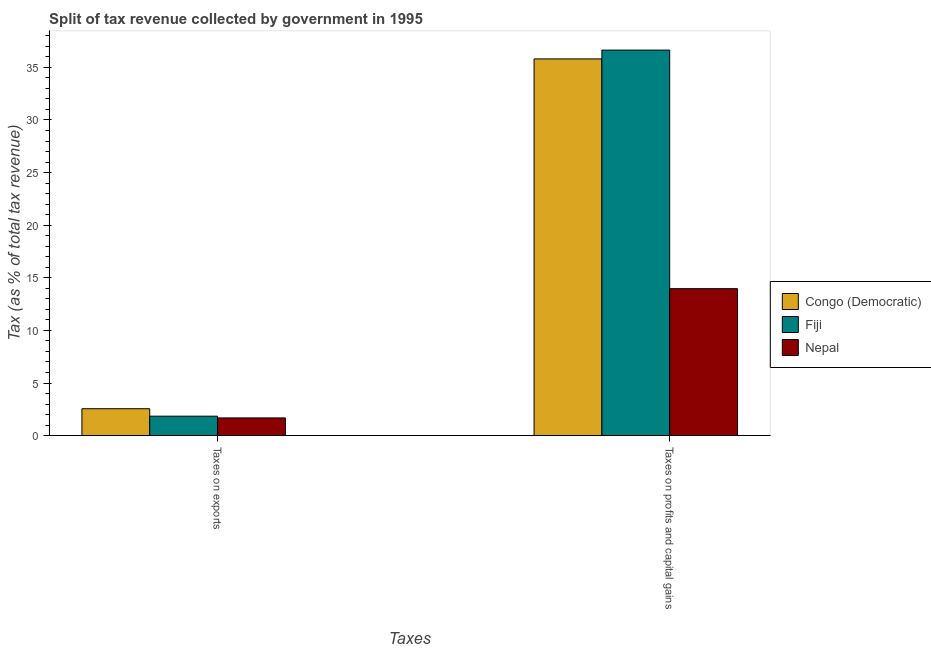How many different coloured bars are there?
Provide a short and direct response. 3. How many groups of bars are there?
Offer a very short reply. 2. How many bars are there on the 1st tick from the right?
Give a very brief answer. 3. What is the label of the 1st group of bars from the left?
Your answer should be very brief. Taxes on exports. What is the percentage of revenue obtained from taxes on profits and capital gains in Nepal?
Your response must be concise. 13.97. Across all countries, what is the maximum percentage of revenue obtained from taxes on exports?
Your response must be concise. 2.56. Across all countries, what is the minimum percentage of revenue obtained from taxes on profits and capital gains?
Offer a terse response. 13.97. In which country was the percentage of revenue obtained from taxes on profits and capital gains maximum?
Your answer should be very brief. Fiji. In which country was the percentage of revenue obtained from taxes on profits and capital gains minimum?
Your response must be concise. Nepal. What is the total percentage of revenue obtained from taxes on exports in the graph?
Keep it short and to the point. 6.09. What is the difference between the percentage of revenue obtained from taxes on profits and capital gains in Fiji and that in Nepal?
Offer a very short reply. 22.67. What is the difference between the percentage of revenue obtained from taxes on profits and capital gains in Fiji and the percentage of revenue obtained from taxes on exports in Nepal?
Your answer should be very brief. 34.96. What is the average percentage of revenue obtained from taxes on profits and capital gains per country?
Give a very brief answer. 28.81. What is the difference between the percentage of revenue obtained from taxes on exports and percentage of revenue obtained from taxes on profits and capital gains in Congo (Democratic)?
Ensure brevity in your answer.  -33.25. What is the ratio of the percentage of revenue obtained from taxes on exports in Congo (Democratic) to that in Fiji?
Keep it short and to the point. 1.38. Is the percentage of revenue obtained from taxes on profits and capital gains in Congo (Democratic) less than that in Fiji?
Keep it short and to the point. Yes. What does the 1st bar from the left in Taxes on exports represents?
Provide a short and direct response. Congo (Democratic). What does the 2nd bar from the right in Taxes on exports represents?
Keep it short and to the point. Fiji. What is the difference between two consecutive major ticks on the Y-axis?
Provide a succinct answer. 5. Does the graph contain grids?
Keep it short and to the point. No. What is the title of the graph?
Ensure brevity in your answer.  Split of tax revenue collected by government in 1995. Does "Myanmar" appear as one of the legend labels in the graph?
Your response must be concise. No. What is the label or title of the X-axis?
Your response must be concise. Taxes. What is the label or title of the Y-axis?
Provide a succinct answer. Tax (as % of total tax revenue). What is the Tax (as % of total tax revenue) of Congo (Democratic) in Taxes on exports?
Offer a very short reply. 2.56. What is the Tax (as % of total tax revenue) of Fiji in Taxes on exports?
Offer a terse response. 1.85. What is the Tax (as % of total tax revenue) of Nepal in Taxes on exports?
Keep it short and to the point. 1.69. What is the Tax (as % of total tax revenue) in Congo (Democratic) in Taxes on profits and capital gains?
Ensure brevity in your answer.  35.81. What is the Tax (as % of total tax revenue) in Fiji in Taxes on profits and capital gains?
Offer a terse response. 36.64. What is the Tax (as % of total tax revenue) of Nepal in Taxes on profits and capital gains?
Offer a very short reply. 13.97. Across all Taxes, what is the maximum Tax (as % of total tax revenue) in Congo (Democratic)?
Ensure brevity in your answer.  35.81. Across all Taxes, what is the maximum Tax (as % of total tax revenue) in Fiji?
Make the answer very short. 36.64. Across all Taxes, what is the maximum Tax (as % of total tax revenue) in Nepal?
Keep it short and to the point. 13.97. Across all Taxes, what is the minimum Tax (as % of total tax revenue) in Congo (Democratic)?
Provide a short and direct response. 2.56. Across all Taxes, what is the minimum Tax (as % of total tax revenue) in Fiji?
Keep it short and to the point. 1.85. Across all Taxes, what is the minimum Tax (as % of total tax revenue) in Nepal?
Offer a very short reply. 1.69. What is the total Tax (as % of total tax revenue) in Congo (Democratic) in the graph?
Your response must be concise. 38.36. What is the total Tax (as % of total tax revenue) of Fiji in the graph?
Provide a succinct answer. 38.49. What is the total Tax (as % of total tax revenue) of Nepal in the graph?
Your answer should be very brief. 15.65. What is the difference between the Tax (as % of total tax revenue) in Congo (Democratic) in Taxes on exports and that in Taxes on profits and capital gains?
Your answer should be compact. -33.25. What is the difference between the Tax (as % of total tax revenue) of Fiji in Taxes on exports and that in Taxes on profits and capital gains?
Your answer should be compact. -34.79. What is the difference between the Tax (as % of total tax revenue) of Nepal in Taxes on exports and that in Taxes on profits and capital gains?
Your response must be concise. -12.28. What is the difference between the Tax (as % of total tax revenue) of Congo (Democratic) in Taxes on exports and the Tax (as % of total tax revenue) of Fiji in Taxes on profits and capital gains?
Give a very brief answer. -34.09. What is the difference between the Tax (as % of total tax revenue) in Congo (Democratic) in Taxes on exports and the Tax (as % of total tax revenue) in Nepal in Taxes on profits and capital gains?
Offer a very short reply. -11.41. What is the difference between the Tax (as % of total tax revenue) of Fiji in Taxes on exports and the Tax (as % of total tax revenue) of Nepal in Taxes on profits and capital gains?
Make the answer very short. -12.12. What is the average Tax (as % of total tax revenue) in Congo (Democratic) per Taxes?
Your response must be concise. 19.18. What is the average Tax (as % of total tax revenue) of Fiji per Taxes?
Offer a terse response. 19.25. What is the average Tax (as % of total tax revenue) in Nepal per Taxes?
Your response must be concise. 7.83. What is the difference between the Tax (as % of total tax revenue) of Congo (Democratic) and Tax (as % of total tax revenue) of Fiji in Taxes on exports?
Give a very brief answer. 0.71. What is the difference between the Tax (as % of total tax revenue) in Congo (Democratic) and Tax (as % of total tax revenue) in Nepal in Taxes on exports?
Your response must be concise. 0.87. What is the difference between the Tax (as % of total tax revenue) of Fiji and Tax (as % of total tax revenue) of Nepal in Taxes on exports?
Offer a terse response. 0.16. What is the difference between the Tax (as % of total tax revenue) in Congo (Democratic) and Tax (as % of total tax revenue) in Fiji in Taxes on profits and capital gains?
Provide a short and direct response. -0.84. What is the difference between the Tax (as % of total tax revenue) in Congo (Democratic) and Tax (as % of total tax revenue) in Nepal in Taxes on profits and capital gains?
Your response must be concise. 21.84. What is the difference between the Tax (as % of total tax revenue) in Fiji and Tax (as % of total tax revenue) in Nepal in Taxes on profits and capital gains?
Provide a short and direct response. 22.67. What is the ratio of the Tax (as % of total tax revenue) of Congo (Democratic) in Taxes on exports to that in Taxes on profits and capital gains?
Offer a terse response. 0.07. What is the ratio of the Tax (as % of total tax revenue) of Fiji in Taxes on exports to that in Taxes on profits and capital gains?
Provide a succinct answer. 0.05. What is the ratio of the Tax (as % of total tax revenue) of Nepal in Taxes on exports to that in Taxes on profits and capital gains?
Ensure brevity in your answer.  0.12. What is the difference between the highest and the second highest Tax (as % of total tax revenue) of Congo (Democratic)?
Make the answer very short. 33.25. What is the difference between the highest and the second highest Tax (as % of total tax revenue) of Fiji?
Ensure brevity in your answer.  34.79. What is the difference between the highest and the second highest Tax (as % of total tax revenue) in Nepal?
Keep it short and to the point. 12.28. What is the difference between the highest and the lowest Tax (as % of total tax revenue) of Congo (Democratic)?
Offer a very short reply. 33.25. What is the difference between the highest and the lowest Tax (as % of total tax revenue) of Fiji?
Ensure brevity in your answer.  34.79. What is the difference between the highest and the lowest Tax (as % of total tax revenue) in Nepal?
Keep it short and to the point. 12.28. 